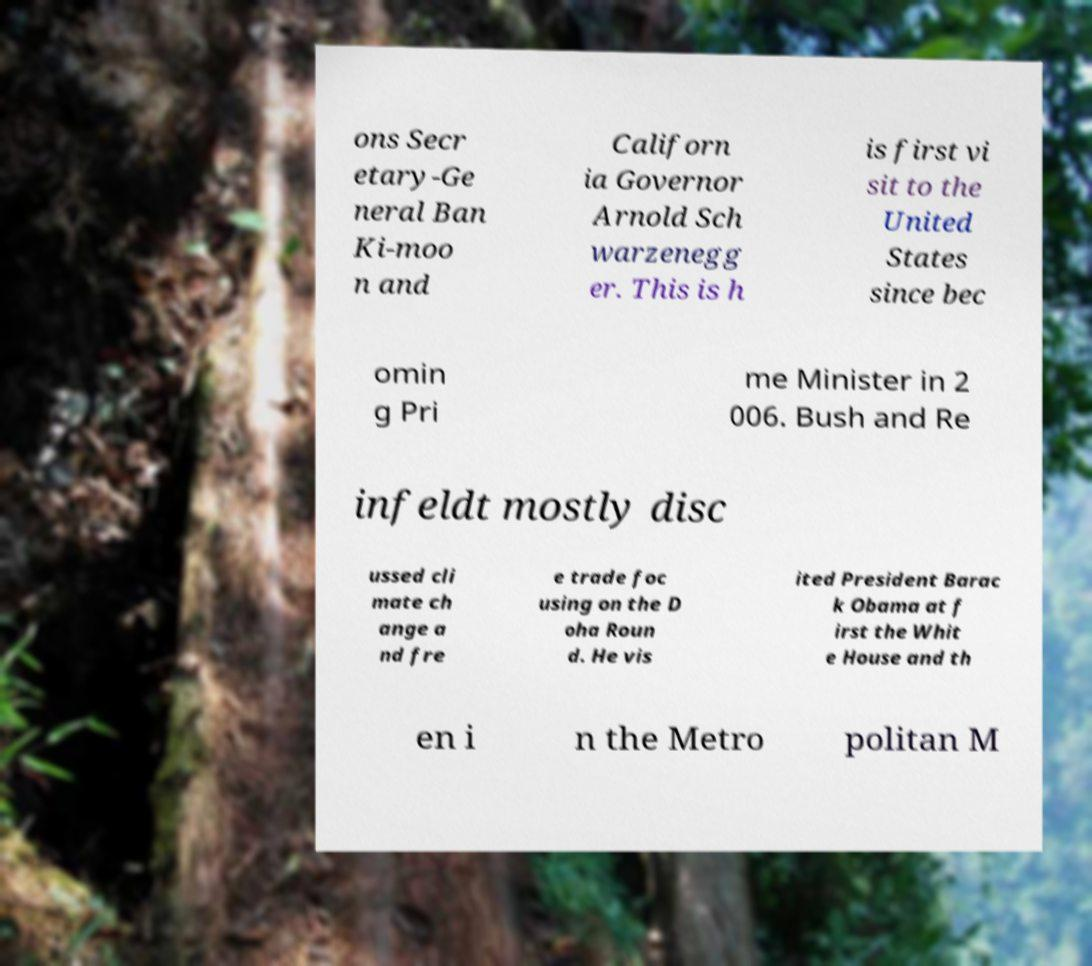Please identify and transcribe the text found in this image. ons Secr etary-Ge neral Ban Ki-moo n and Californ ia Governor Arnold Sch warzenegg er. This is h is first vi sit to the United States since bec omin g Pri me Minister in 2 006. Bush and Re infeldt mostly disc ussed cli mate ch ange a nd fre e trade foc using on the D oha Roun d. He vis ited President Barac k Obama at f irst the Whit e House and th en i n the Metro politan M 